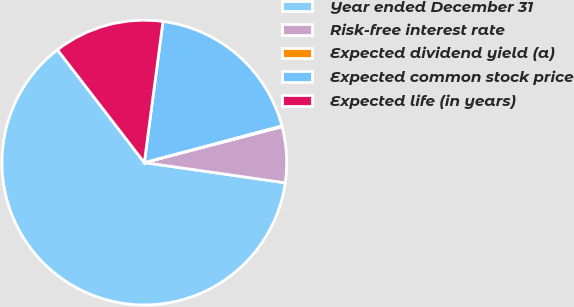Convert chart to OTSL. <chart><loc_0><loc_0><loc_500><loc_500><pie_chart><fcel>Year ended December 31<fcel>Risk-free interest rate<fcel>Expected dividend yield (a)<fcel>Expected common stock price<fcel>Expected life (in years)<nl><fcel>62.29%<fcel>6.32%<fcel>0.1%<fcel>18.76%<fcel>12.54%<nl></chart> 